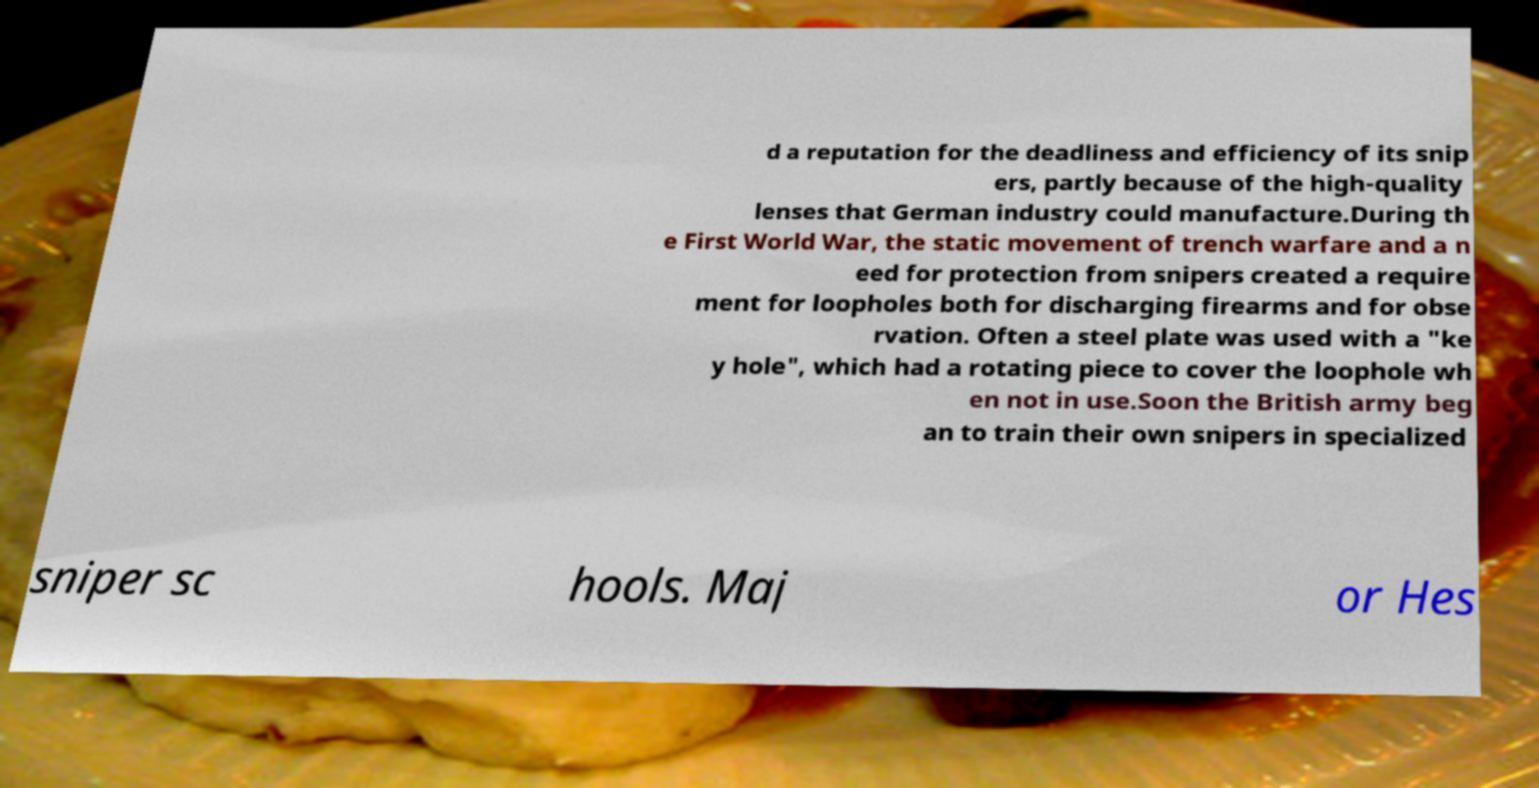For documentation purposes, I need the text within this image transcribed. Could you provide that? d a reputation for the deadliness and efficiency of its snip ers, partly because of the high-quality lenses that German industry could manufacture.During th e First World War, the static movement of trench warfare and a n eed for protection from snipers created a require ment for loopholes both for discharging firearms and for obse rvation. Often a steel plate was used with a "ke y hole", which had a rotating piece to cover the loophole wh en not in use.Soon the British army beg an to train their own snipers in specialized sniper sc hools. Maj or Hes 